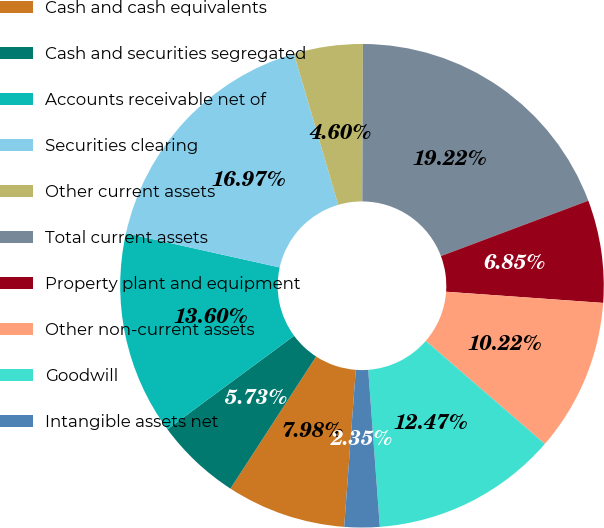<chart> <loc_0><loc_0><loc_500><loc_500><pie_chart><fcel>Cash and cash equivalents<fcel>Cash and securities segregated<fcel>Accounts receivable net of<fcel>Securities clearing<fcel>Other current assets<fcel>Total current assets<fcel>Property plant and equipment<fcel>Other non-current assets<fcel>Goodwill<fcel>Intangible assets net<nl><fcel>7.98%<fcel>5.73%<fcel>13.6%<fcel>16.97%<fcel>4.6%<fcel>19.22%<fcel>6.85%<fcel>10.22%<fcel>12.47%<fcel>2.35%<nl></chart> 